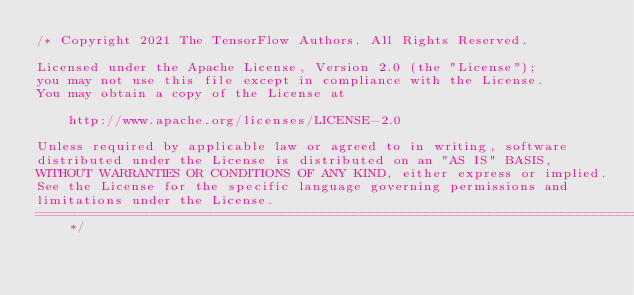Convert code to text. <code><loc_0><loc_0><loc_500><loc_500><_C++_>/* Copyright 2021 The TensorFlow Authors. All Rights Reserved.

Licensed under the Apache License, Version 2.0 (the "License");
you may not use this file except in compliance with the License.
You may obtain a copy of the License at

    http://www.apache.org/licenses/LICENSE-2.0

Unless required by applicable law or agreed to in writing, software
distributed under the License is distributed on an "AS IS" BASIS,
WITHOUT WARRANTIES OR CONDITIONS OF ANY KIND, either express or implied.
See the License for the specific language governing permissions and
limitations under the License.
==============================================================================*/</code> 